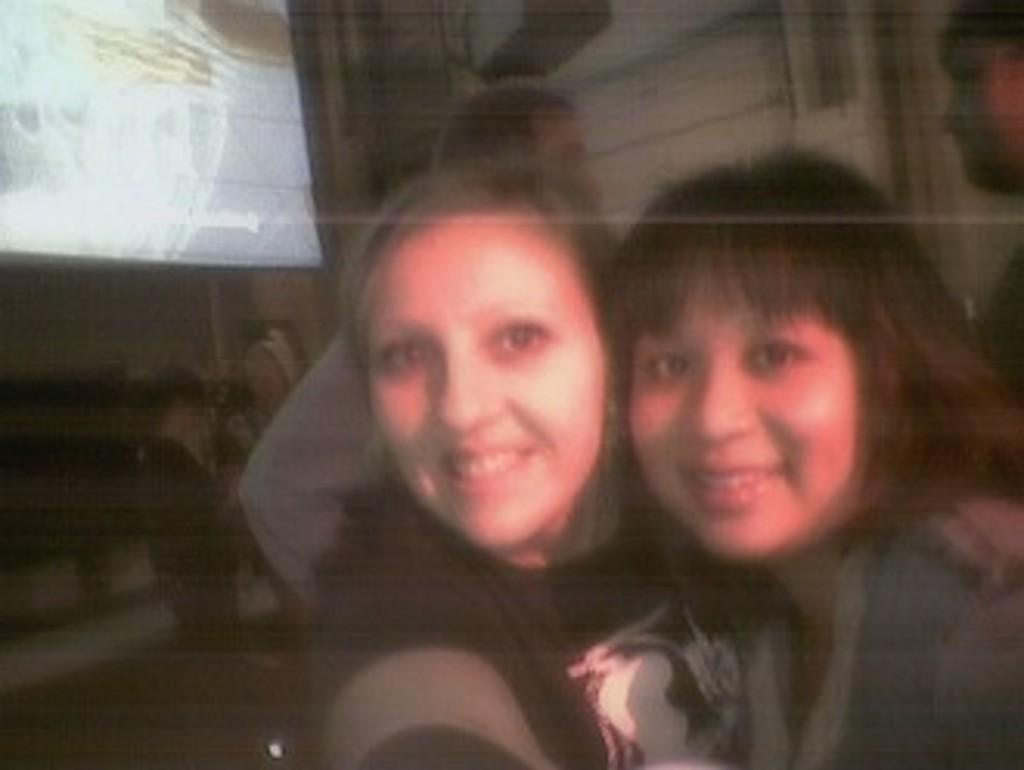How many ladies are in the image? There are two ladies in the image. What expression do the ladies have? The ladies are smiling. Can you describe the background of the image? There are people standing in the background of the image. What is located on the left side of the image? There is a board and a wall on the left side of the image. What type of canvas is the secretary using in the image? There is no canvas or secretary present in the image. 